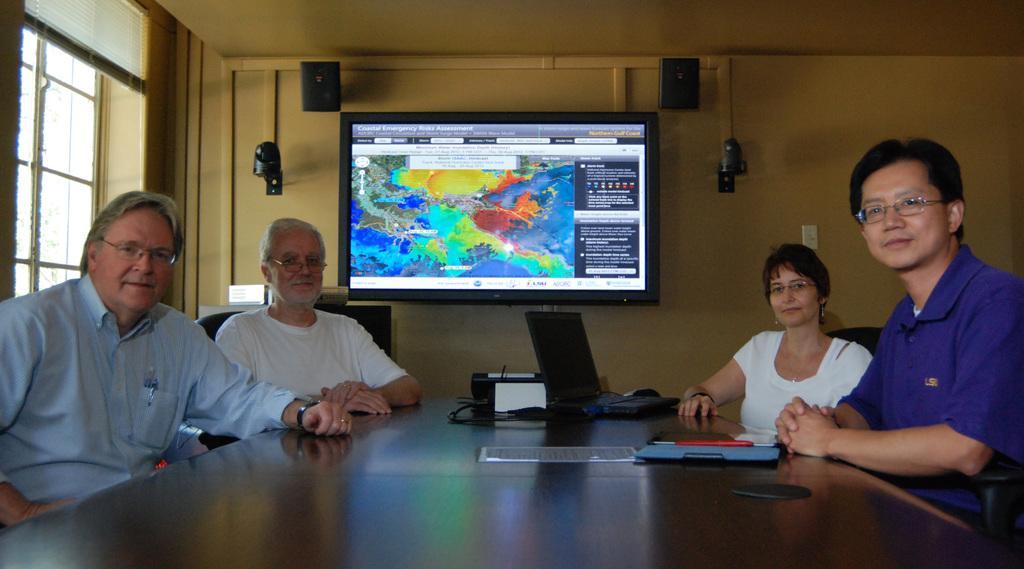In one or two sentences, can you explain what this image depicts? Here I can see four people sitting around a table, smiling and giving pose for the picture. On this table a laptop, a device and papers are placed. In the background there is a monitor attached to the wall. Around the monitor there are few devices also attached to the wall. On the left side there is a window. 